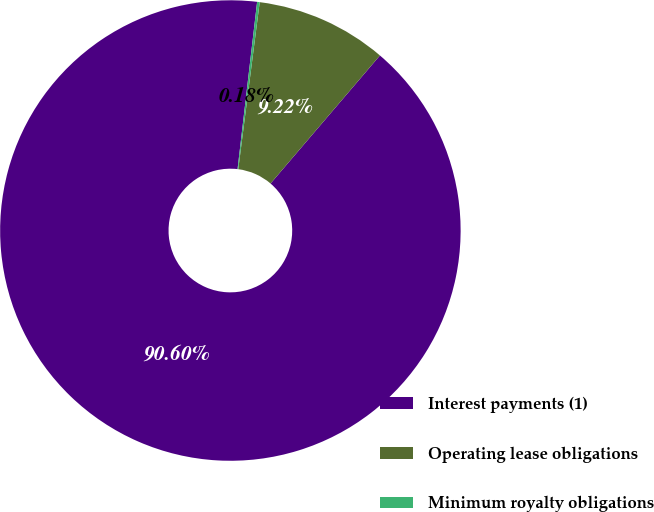Convert chart to OTSL. <chart><loc_0><loc_0><loc_500><loc_500><pie_chart><fcel>Interest payments (1)<fcel>Operating lease obligations<fcel>Minimum royalty obligations<nl><fcel>90.61%<fcel>9.22%<fcel>0.18%<nl></chart> 